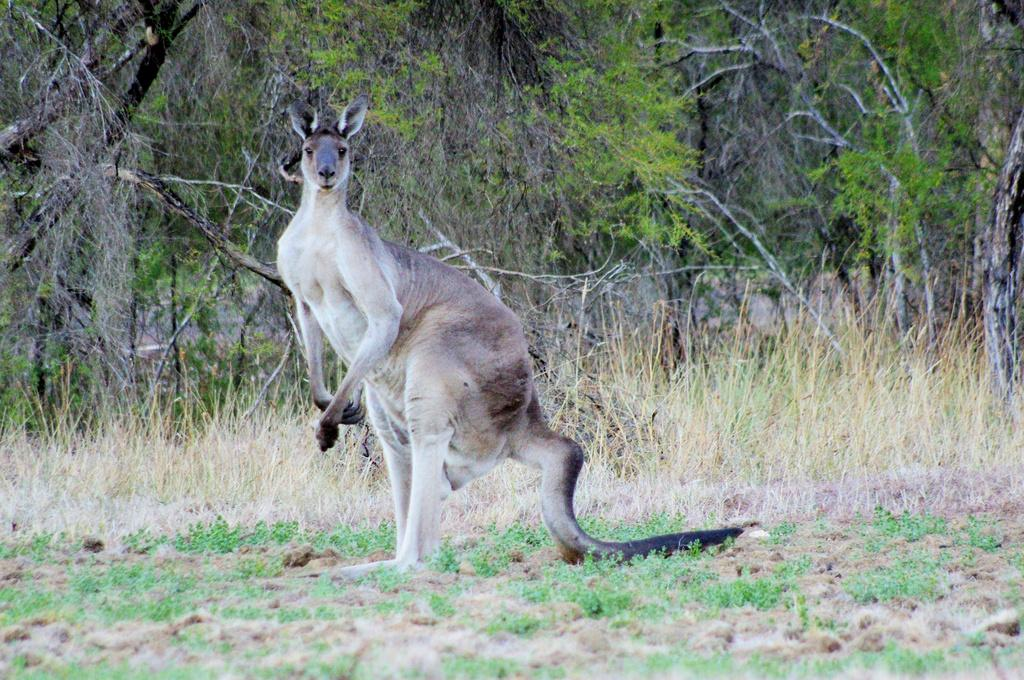What animal is located in the middle of the image? There is a kangaroo in the middle of the image. What type of vegetation can be seen in the background of the image? There is grass and trees in the background of the image. What type of wrist accessory is the kangaroo wearing in the image? The kangaroo is not wearing any wrist accessory in the image. What type of corn can be seen growing in the background of the image? There is no corn present in the image; it features a kangaroo, grass, and trees in the background. 